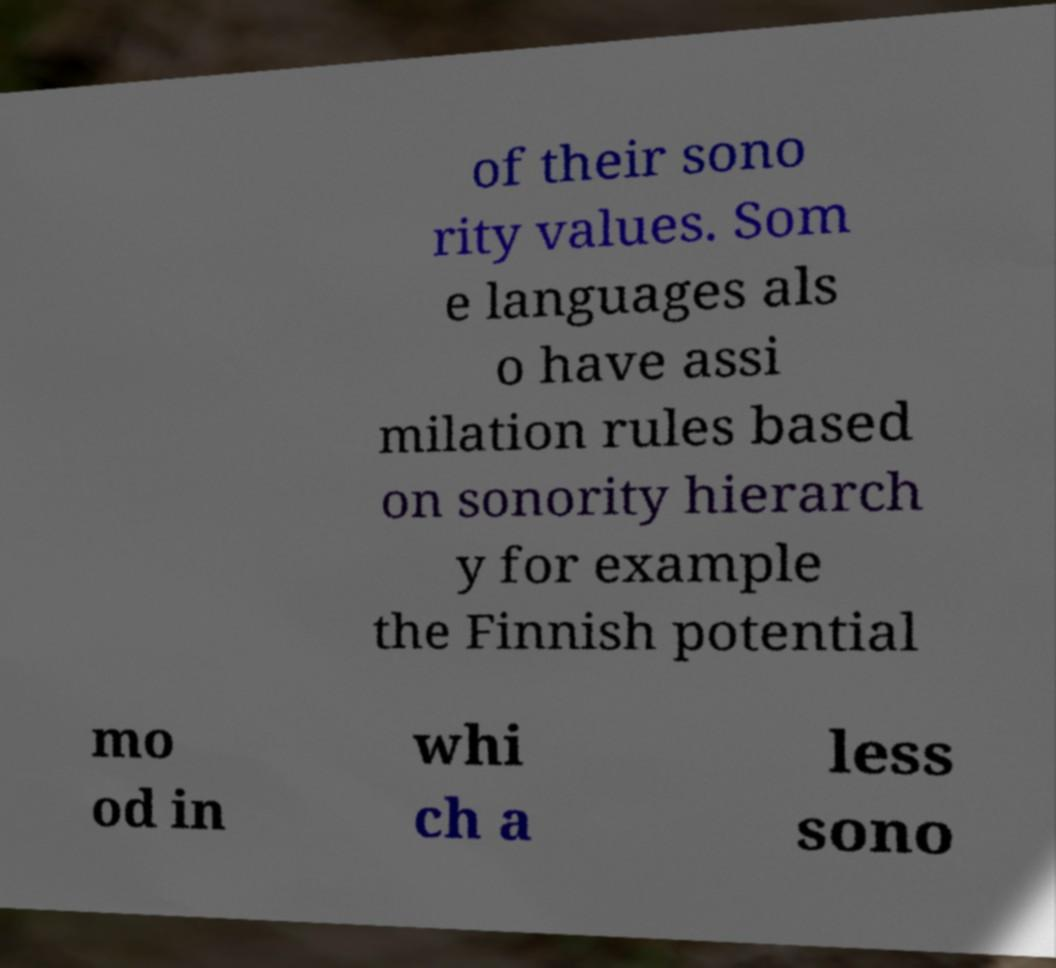There's text embedded in this image that I need extracted. Can you transcribe it verbatim? of their sono rity values. Som e languages als o have assi milation rules based on sonority hierarch y for example the Finnish potential mo od in whi ch a less sono 